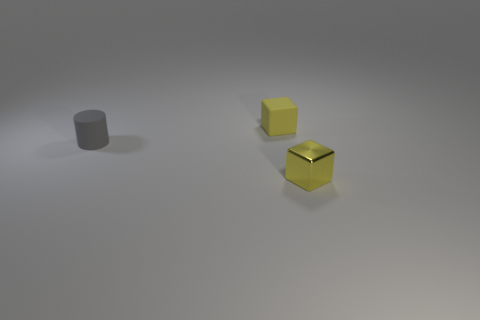Add 1 brown rubber cylinders. How many objects exist? 4 Subtract all cubes. How many objects are left? 1 Add 2 metal blocks. How many metal blocks are left? 3 Add 1 yellow things. How many yellow things exist? 3 Subtract 0 cyan blocks. How many objects are left? 3 Subtract all small yellow objects. Subtract all tiny cylinders. How many objects are left? 0 